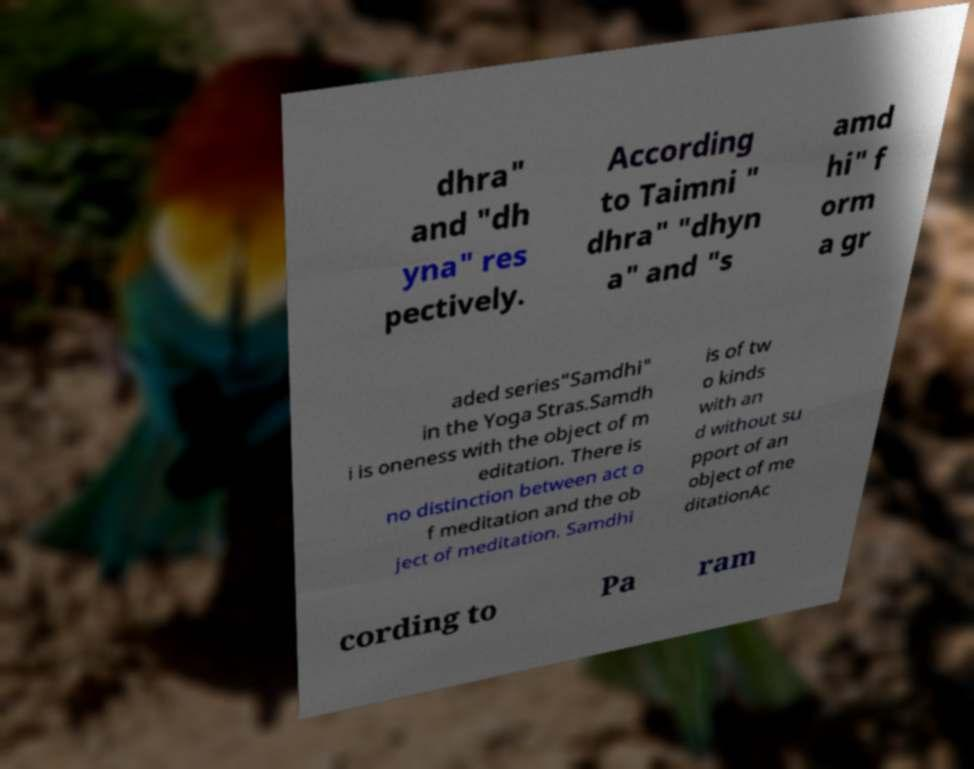For documentation purposes, I need the text within this image transcribed. Could you provide that? dhra" and "dh yna" res pectively. According to Taimni " dhra" "dhyn a" and "s amd hi" f orm a gr aded series"Samdhi" in the Yoga Stras.Samdh i is oneness with the object of m editation. There is no distinction between act o f meditation and the ob ject of meditation. Samdhi is of tw o kinds with an d without su pport of an object of me ditationAc cording to Pa ram 